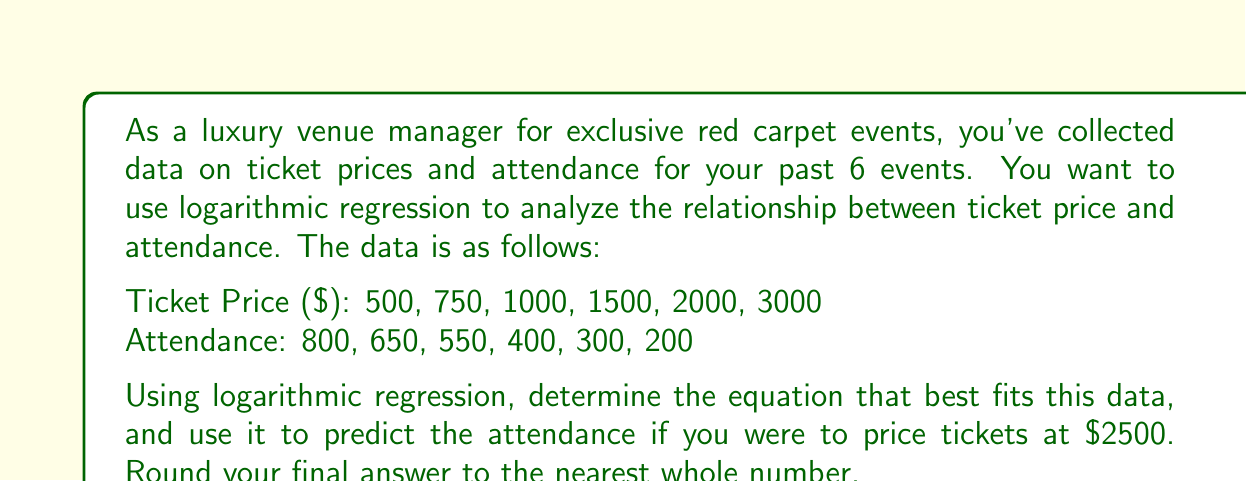Can you solve this math problem? To solve this problem, we'll use logarithmic regression in the form $y = a \ln(x) + b$, where $y$ is the attendance and $x$ is the ticket price.

1. First, we need to calculate the following sums:
   $$\sum \ln(x), \sum y, \sum (\ln(x))^2, \sum (y \ln(x))$$

   $\sum \ln(x) = \ln(500) + \ln(750) + \ln(1000) + \ln(1500) + \ln(2000) + \ln(3000) = 46.229$
   $\sum y = 800 + 650 + 550 + 400 + 300 + 200 = 2900$
   $\sum (\ln(x))^2 = (\ln(500))^2 + (\ln(750))^2 + ... + (\ln(3000))^2 = 359.845$
   $\sum (y \ln(x)) = 800\ln(500) + 650\ln(750) + ... + 200\ln(3000) = 21,862.468$

2. Now we can use these formulas to find $a$ and $b$:
   $$a = \frac{n\sum(y\ln(x)) - \sum y \sum \ln(x)}{n\sum(\ln(x))^2 - (\sum \ln(x))^2}$$
   $$b = \frac{\sum y - a\sum \ln(x)}{n}$$

   Where $n = 6$ (number of data points)

3. Plugging in our values:
   $$a = \frac{6(21,862.468) - 2900(46.229)}{6(359.845) - (46.229)^2} = -403.176$$
   $$b = \frac{2900 - (-403.176)(46.229)}{6} = 1,850.145$$

4. Our logarithmic regression equation is:
   $$y = -403.176 \ln(x) + 1,850.145$$

5. To predict attendance for a ticket price of $2500:
   $$y = -403.176 \ln(2500) + 1,850.145 = 246.827$$

6. Rounding to the nearest whole number: 247
Answer: 247 attendees 